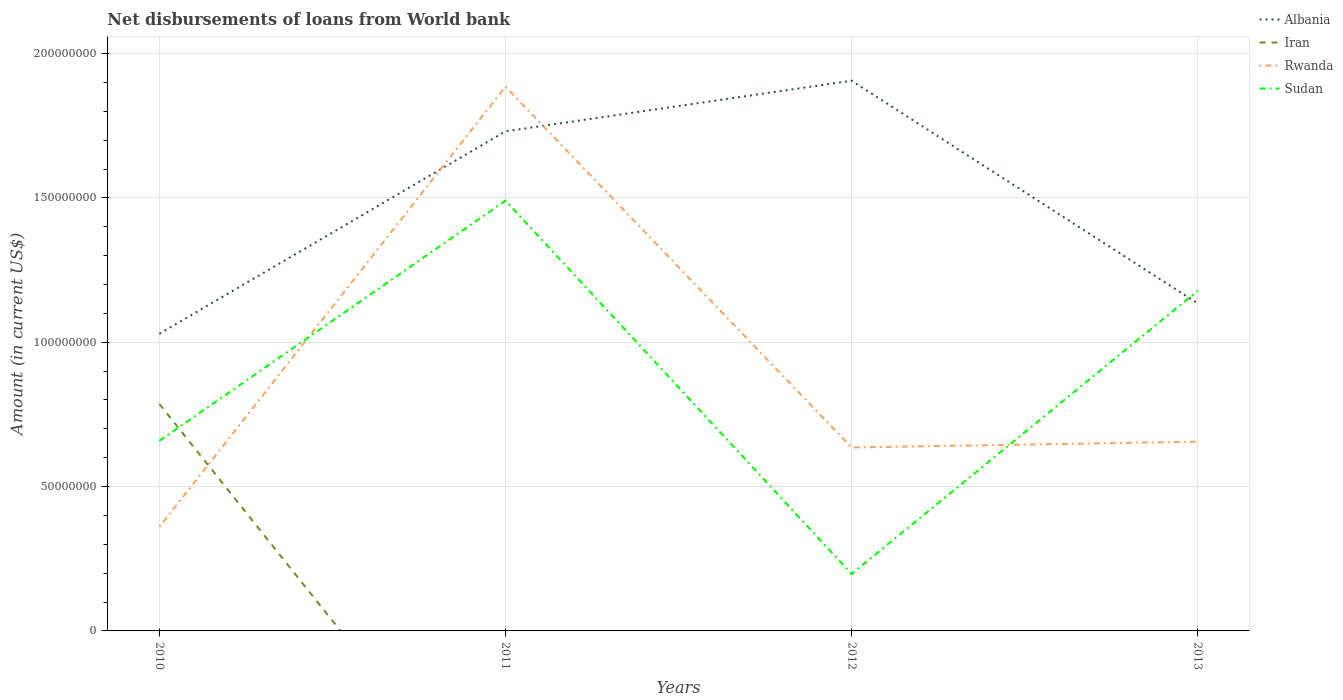How many different coloured lines are there?
Provide a short and direct response. 4. Does the line corresponding to Albania intersect with the line corresponding to Iran?
Provide a short and direct response. No. Is the number of lines equal to the number of legend labels?
Offer a very short reply. No. Across all years, what is the maximum amount of loan disbursed from World Bank in Rwanda?
Offer a very short reply. 3.60e+07. What is the total amount of loan disbursed from World Bank in Sudan in the graph?
Your response must be concise. 1.29e+08. What is the difference between the highest and the second highest amount of loan disbursed from World Bank in Rwanda?
Give a very brief answer. 1.52e+08. How many lines are there?
Your answer should be compact. 4. What is the difference between two consecutive major ticks on the Y-axis?
Your answer should be very brief. 5.00e+07. Where does the legend appear in the graph?
Offer a terse response. Top right. How many legend labels are there?
Provide a short and direct response. 4. What is the title of the graph?
Give a very brief answer. Net disbursements of loans from World bank. What is the Amount (in current US$) in Albania in 2010?
Your response must be concise. 1.03e+08. What is the Amount (in current US$) in Iran in 2010?
Your answer should be very brief. 7.86e+07. What is the Amount (in current US$) in Rwanda in 2010?
Ensure brevity in your answer.  3.60e+07. What is the Amount (in current US$) of Sudan in 2010?
Your answer should be very brief. 6.59e+07. What is the Amount (in current US$) of Albania in 2011?
Your response must be concise. 1.73e+08. What is the Amount (in current US$) of Rwanda in 2011?
Your answer should be very brief. 1.89e+08. What is the Amount (in current US$) in Sudan in 2011?
Keep it short and to the point. 1.49e+08. What is the Amount (in current US$) of Albania in 2012?
Give a very brief answer. 1.91e+08. What is the Amount (in current US$) in Iran in 2012?
Provide a succinct answer. 0. What is the Amount (in current US$) in Rwanda in 2012?
Your answer should be very brief. 6.35e+07. What is the Amount (in current US$) in Sudan in 2012?
Your answer should be very brief. 1.97e+07. What is the Amount (in current US$) of Albania in 2013?
Offer a terse response. 1.13e+08. What is the Amount (in current US$) of Rwanda in 2013?
Offer a terse response. 6.55e+07. What is the Amount (in current US$) of Sudan in 2013?
Ensure brevity in your answer.  1.18e+08. Across all years, what is the maximum Amount (in current US$) of Albania?
Your answer should be very brief. 1.91e+08. Across all years, what is the maximum Amount (in current US$) in Iran?
Your answer should be compact. 7.86e+07. Across all years, what is the maximum Amount (in current US$) in Rwanda?
Provide a succinct answer. 1.89e+08. Across all years, what is the maximum Amount (in current US$) of Sudan?
Ensure brevity in your answer.  1.49e+08. Across all years, what is the minimum Amount (in current US$) of Albania?
Your answer should be very brief. 1.03e+08. Across all years, what is the minimum Amount (in current US$) in Rwanda?
Your answer should be very brief. 3.60e+07. Across all years, what is the minimum Amount (in current US$) in Sudan?
Make the answer very short. 1.97e+07. What is the total Amount (in current US$) of Albania in the graph?
Your response must be concise. 5.80e+08. What is the total Amount (in current US$) in Iran in the graph?
Provide a succinct answer. 7.86e+07. What is the total Amount (in current US$) in Rwanda in the graph?
Your response must be concise. 3.54e+08. What is the total Amount (in current US$) of Sudan in the graph?
Your answer should be compact. 3.52e+08. What is the difference between the Amount (in current US$) of Albania in 2010 and that in 2011?
Your answer should be compact. -7.01e+07. What is the difference between the Amount (in current US$) in Rwanda in 2010 and that in 2011?
Offer a terse response. -1.52e+08. What is the difference between the Amount (in current US$) of Sudan in 2010 and that in 2011?
Your answer should be compact. -8.32e+07. What is the difference between the Amount (in current US$) in Albania in 2010 and that in 2012?
Your response must be concise. -8.77e+07. What is the difference between the Amount (in current US$) of Rwanda in 2010 and that in 2012?
Make the answer very short. -2.75e+07. What is the difference between the Amount (in current US$) in Sudan in 2010 and that in 2012?
Make the answer very short. 4.61e+07. What is the difference between the Amount (in current US$) in Albania in 2010 and that in 2013?
Give a very brief answer. -1.05e+07. What is the difference between the Amount (in current US$) in Rwanda in 2010 and that in 2013?
Your answer should be compact. -2.95e+07. What is the difference between the Amount (in current US$) of Sudan in 2010 and that in 2013?
Provide a succinct answer. -5.19e+07. What is the difference between the Amount (in current US$) in Albania in 2011 and that in 2012?
Provide a short and direct response. -1.75e+07. What is the difference between the Amount (in current US$) of Rwanda in 2011 and that in 2012?
Your answer should be compact. 1.25e+08. What is the difference between the Amount (in current US$) in Sudan in 2011 and that in 2012?
Your answer should be very brief. 1.29e+08. What is the difference between the Amount (in current US$) in Albania in 2011 and that in 2013?
Keep it short and to the point. 5.96e+07. What is the difference between the Amount (in current US$) of Rwanda in 2011 and that in 2013?
Your answer should be very brief. 1.23e+08. What is the difference between the Amount (in current US$) in Sudan in 2011 and that in 2013?
Your answer should be compact. 3.12e+07. What is the difference between the Amount (in current US$) of Albania in 2012 and that in 2013?
Keep it short and to the point. 7.71e+07. What is the difference between the Amount (in current US$) in Rwanda in 2012 and that in 2013?
Give a very brief answer. -2.00e+06. What is the difference between the Amount (in current US$) of Sudan in 2012 and that in 2013?
Provide a succinct answer. -9.81e+07. What is the difference between the Amount (in current US$) of Albania in 2010 and the Amount (in current US$) of Rwanda in 2011?
Keep it short and to the point. -8.56e+07. What is the difference between the Amount (in current US$) of Albania in 2010 and the Amount (in current US$) of Sudan in 2011?
Keep it short and to the point. -4.61e+07. What is the difference between the Amount (in current US$) of Iran in 2010 and the Amount (in current US$) of Rwanda in 2011?
Provide a succinct answer. -1.10e+08. What is the difference between the Amount (in current US$) in Iran in 2010 and the Amount (in current US$) in Sudan in 2011?
Provide a short and direct response. -7.04e+07. What is the difference between the Amount (in current US$) of Rwanda in 2010 and the Amount (in current US$) of Sudan in 2011?
Your answer should be compact. -1.13e+08. What is the difference between the Amount (in current US$) in Albania in 2010 and the Amount (in current US$) in Rwanda in 2012?
Your answer should be compact. 3.94e+07. What is the difference between the Amount (in current US$) in Albania in 2010 and the Amount (in current US$) in Sudan in 2012?
Provide a short and direct response. 8.32e+07. What is the difference between the Amount (in current US$) of Iran in 2010 and the Amount (in current US$) of Rwanda in 2012?
Your answer should be very brief. 1.51e+07. What is the difference between the Amount (in current US$) of Iran in 2010 and the Amount (in current US$) of Sudan in 2012?
Give a very brief answer. 5.89e+07. What is the difference between the Amount (in current US$) in Rwanda in 2010 and the Amount (in current US$) in Sudan in 2012?
Make the answer very short. 1.63e+07. What is the difference between the Amount (in current US$) in Albania in 2010 and the Amount (in current US$) in Rwanda in 2013?
Your answer should be compact. 3.74e+07. What is the difference between the Amount (in current US$) of Albania in 2010 and the Amount (in current US$) of Sudan in 2013?
Offer a terse response. -1.49e+07. What is the difference between the Amount (in current US$) of Iran in 2010 and the Amount (in current US$) of Rwanda in 2013?
Provide a short and direct response. 1.31e+07. What is the difference between the Amount (in current US$) in Iran in 2010 and the Amount (in current US$) in Sudan in 2013?
Provide a succinct answer. -3.92e+07. What is the difference between the Amount (in current US$) of Rwanda in 2010 and the Amount (in current US$) of Sudan in 2013?
Offer a very short reply. -8.17e+07. What is the difference between the Amount (in current US$) in Albania in 2011 and the Amount (in current US$) in Rwanda in 2012?
Provide a succinct answer. 1.09e+08. What is the difference between the Amount (in current US$) in Albania in 2011 and the Amount (in current US$) in Sudan in 2012?
Provide a succinct answer. 1.53e+08. What is the difference between the Amount (in current US$) of Rwanda in 2011 and the Amount (in current US$) of Sudan in 2012?
Ensure brevity in your answer.  1.69e+08. What is the difference between the Amount (in current US$) of Albania in 2011 and the Amount (in current US$) of Rwanda in 2013?
Keep it short and to the point. 1.07e+08. What is the difference between the Amount (in current US$) of Albania in 2011 and the Amount (in current US$) of Sudan in 2013?
Provide a succinct answer. 5.52e+07. What is the difference between the Amount (in current US$) in Rwanda in 2011 and the Amount (in current US$) in Sudan in 2013?
Give a very brief answer. 7.07e+07. What is the difference between the Amount (in current US$) of Albania in 2012 and the Amount (in current US$) of Rwanda in 2013?
Give a very brief answer. 1.25e+08. What is the difference between the Amount (in current US$) in Albania in 2012 and the Amount (in current US$) in Sudan in 2013?
Your answer should be very brief. 7.28e+07. What is the difference between the Amount (in current US$) in Rwanda in 2012 and the Amount (in current US$) in Sudan in 2013?
Your answer should be compact. -5.42e+07. What is the average Amount (in current US$) in Albania per year?
Your answer should be compact. 1.45e+08. What is the average Amount (in current US$) in Iran per year?
Your answer should be very brief. 1.97e+07. What is the average Amount (in current US$) of Rwanda per year?
Ensure brevity in your answer.  8.84e+07. What is the average Amount (in current US$) of Sudan per year?
Provide a succinct answer. 8.81e+07. In the year 2010, what is the difference between the Amount (in current US$) of Albania and Amount (in current US$) of Iran?
Provide a succinct answer. 2.43e+07. In the year 2010, what is the difference between the Amount (in current US$) of Albania and Amount (in current US$) of Rwanda?
Offer a terse response. 6.69e+07. In the year 2010, what is the difference between the Amount (in current US$) in Albania and Amount (in current US$) in Sudan?
Your response must be concise. 3.71e+07. In the year 2010, what is the difference between the Amount (in current US$) of Iran and Amount (in current US$) of Rwanda?
Make the answer very short. 4.26e+07. In the year 2010, what is the difference between the Amount (in current US$) of Iran and Amount (in current US$) of Sudan?
Give a very brief answer. 1.28e+07. In the year 2010, what is the difference between the Amount (in current US$) in Rwanda and Amount (in current US$) in Sudan?
Give a very brief answer. -2.98e+07. In the year 2011, what is the difference between the Amount (in current US$) of Albania and Amount (in current US$) of Rwanda?
Offer a terse response. -1.55e+07. In the year 2011, what is the difference between the Amount (in current US$) in Albania and Amount (in current US$) in Sudan?
Your response must be concise. 2.40e+07. In the year 2011, what is the difference between the Amount (in current US$) in Rwanda and Amount (in current US$) in Sudan?
Your answer should be compact. 3.95e+07. In the year 2012, what is the difference between the Amount (in current US$) in Albania and Amount (in current US$) in Rwanda?
Make the answer very short. 1.27e+08. In the year 2012, what is the difference between the Amount (in current US$) of Albania and Amount (in current US$) of Sudan?
Keep it short and to the point. 1.71e+08. In the year 2012, what is the difference between the Amount (in current US$) in Rwanda and Amount (in current US$) in Sudan?
Give a very brief answer. 4.38e+07. In the year 2013, what is the difference between the Amount (in current US$) in Albania and Amount (in current US$) in Rwanda?
Provide a short and direct response. 4.79e+07. In the year 2013, what is the difference between the Amount (in current US$) in Albania and Amount (in current US$) in Sudan?
Keep it short and to the point. -4.32e+06. In the year 2013, what is the difference between the Amount (in current US$) in Rwanda and Amount (in current US$) in Sudan?
Provide a short and direct response. -5.22e+07. What is the ratio of the Amount (in current US$) in Albania in 2010 to that in 2011?
Offer a very short reply. 0.59. What is the ratio of the Amount (in current US$) of Rwanda in 2010 to that in 2011?
Your response must be concise. 0.19. What is the ratio of the Amount (in current US$) of Sudan in 2010 to that in 2011?
Ensure brevity in your answer.  0.44. What is the ratio of the Amount (in current US$) in Albania in 2010 to that in 2012?
Keep it short and to the point. 0.54. What is the ratio of the Amount (in current US$) of Rwanda in 2010 to that in 2012?
Offer a terse response. 0.57. What is the ratio of the Amount (in current US$) in Sudan in 2010 to that in 2012?
Keep it short and to the point. 3.34. What is the ratio of the Amount (in current US$) in Albania in 2010 to that in 2013?
Provide a short and direct response. 0.91. What is the ratio of the Amount (in current US$) in Rwanda in 2010 to that in 2013?
Provide a succinct answer. 0.55. What is the ratio of the Amount (in current US$) in Sudan in 2010 to that in 2013?
Make the answer very short. 0.56. What is the ratio of the Amount (in current US$) in Albania in 2011 to that in 2012?
Offer a very short reply. 0.91. What is the ratio of the Amount (in current US$) in Rwanda in 2011 to that in 2012?
Provide a short and direct response. 2.97. What is the ratio of the Amount (in current US$) of Sudan in 2011 to that in 2012?
Your answer should be compact. 7.55. What is the ratio of the Amount (in current US$) in Albania in 2011 to that in 2013?
Give a very brief answer. 1.52. What is the ratio of the Amount (in current US$) of Rwanda in 2011 to that in 2013?
Offer a very short reply. 2.88. What is the ratio of the Amount (in current US$) in Sudan in 2011 to that in 2013?
Your answer should be compact. 1.27. What is the ratio of the Amount (in current US$) of Albania in 2012 to that in 2013?
Ensure brevity in your answer.  1.68. What is the ratio of the Amount (in current US$) in Rwanda in 2012 to that in 2013?
Your answer should be very brief. 0.97. What is the ratio of the Amount (in current US$) in Sudan in 2012 to that in 2013?
Provide a short and direct response. 0.17. What is the difference between the highest and the second highest Amount (in current US$) of Albania?
Make the answer very short. 1.75e+07. What is the difference between the highest and the second highest Amount (in current US$) of Rwanda?
Provide a succinct answer. 1.23e+08. What is the difference between the highest and the second highest Amount (in current US$) of Sudan?
Make the answer very short. 3.12e+07. What is the difference between the highest and the lowest Amount (in current US$) in Albania?
Ensure brevity in your answer.  8.77e+07. What is the difference between the highest and the lowest Amount (in current US$) in Iran?
Provide a short and direct response. 7.86e+07. What is the difference between the highest and the lowest Amount (in current US$) in Rwanda?
Your answer should be very brief. 1.52e+08. What is the difference between the highest and the lowest Amount (in current US$) of Sudan?
Offer a very short reply. 1.29e+08. 